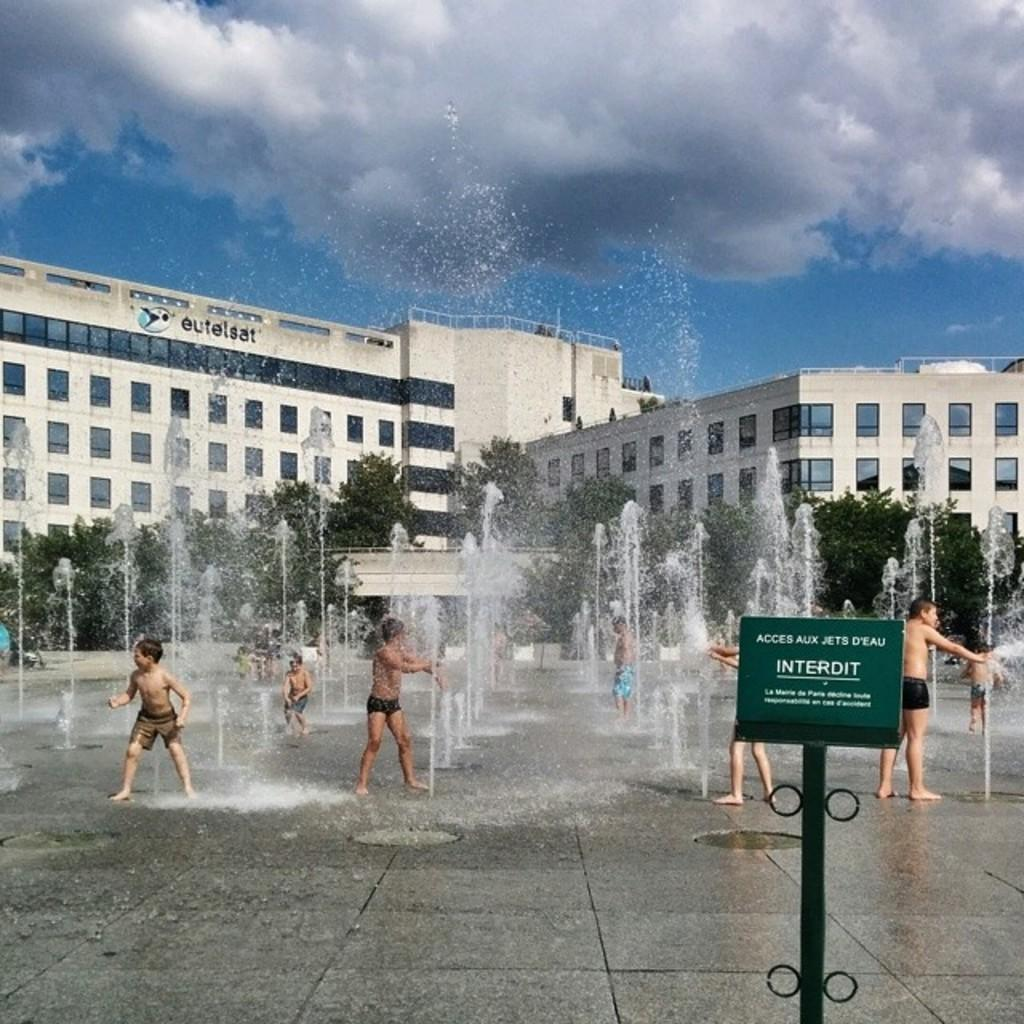What type of structures can be seen in the image? There are buildings in the image. What architectural features can be observed on the buildings? Windows are visible in the image. What natural elements are present in the image? There are trees and water visible in the image. What additional objects can be seen in the image? There is a board and a pole in the image. Are there any living beings in the image? Yes, there are people in the image. What is the color of the sky in the image? The sky is blue and white in color. Where is the doll located in the image? There is no doll present in the image. What type of business is being conducted in the image? The image does not depict any specific business activity. 